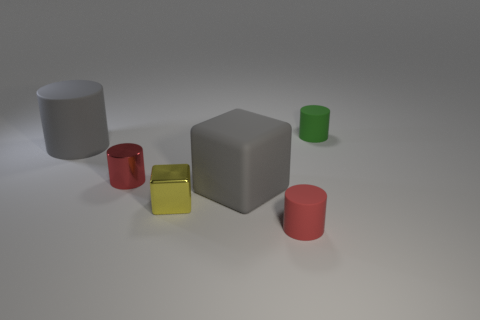There is a gray block that is the same size as the gray matte cylinder; what is its material?
Your answer should be compact. Rubber. Does the small red rubber thing have the same shape as the green thing?
Offer a very short reply. Yes. The other big thing that is the same shape as the red shiny thing is what color?
Ensure brevity in your answer.  Gray. There is a tiny object that is behind the gray matte cylinder; what is its shape?
Ensure brevity in your answer.  Cylinder. What number of red rubber objects have the same shape as the tiny green matte thing?
Your answer should be very brief. 1. There is a rubber cylinder in front of the small yellow block; is it the same color as the metallic cylinder to the right of the large gray cylinder?
Offer a very short reply. Yes. How many things are rubber cylinders or metal objects?
Make the answer very short. 5. What number of objects are made of the same material as the yellow block?
Your response must be concise. 1. Is the number of gray rubber cylinders less than the number of small cyan cylinders?
Provide a short and direct response. No. Is the material of the gray thing that is in front of the big gray matte cylinder the same as the small block?
Offer a very short reply. No. 